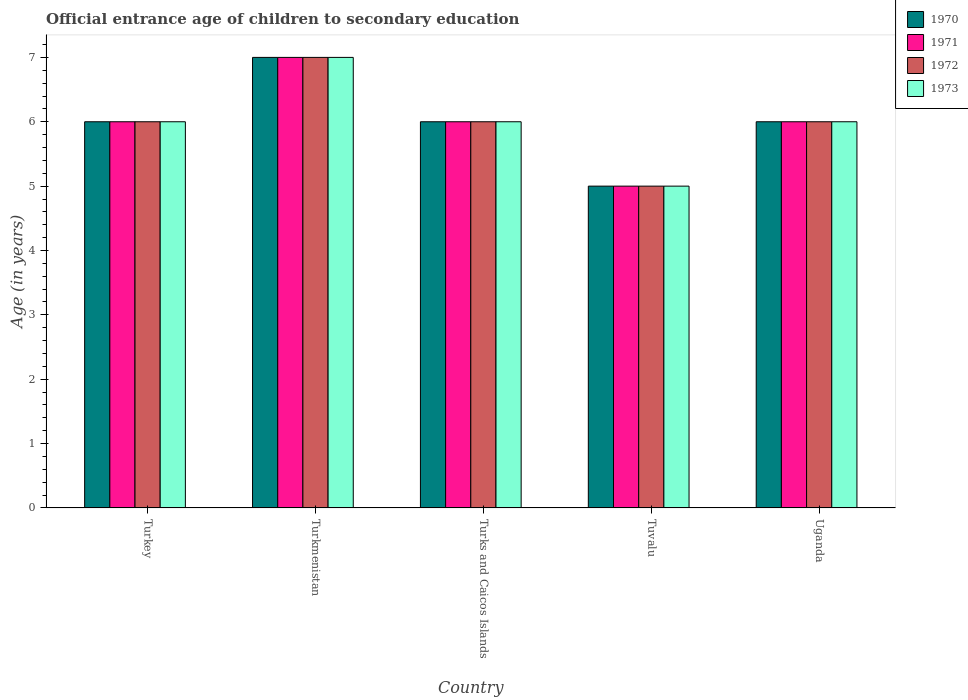How many different coloured bars are there?
Give a very brief answer. 4. Are the number of bars per tick equal to the number of legend labels?
Ensure brevity in your answer.  Yes. How many bars are there on the 3rd tick from the right?
Your response must be concise. 4. What is the label of the 2nd group of bars from the left?
Provide a short and direct response. Turkmenistan. What is the secondary school starting age of children in 1970 in Turkmenistan?
Ensure brevity in your answer.  7. Across all countries, what is the maximum secondary school starting age of children in 1970?
Provide a succinct answer. 7. In which country was the secondary school starting age of children in 1971 maximum?
Give a very brief answer. Turkmenistan. In which country was the secondary school starting age of children in 1972 minimum?
Provide a succinct answer. Tuvalu. What is the difference between the secondary school starting age of children in 1972 in Turks and Caicos Islands and that in Uganda?
Your answer should be compact. 0. What is the average secondary school starting age of children in 1971 per country?
Ensure brevity in your answer.  6. What is the ratio of the secondary school starting age of children in 1973 in Turkey to that in Turks and Caicos Islands?
Offer a very short reply. 1. Is the difference between the secondary school starting age of children in 1973 in Turks and Caicos Islands and Uganda greater than the difference between the secondary school starting age of children in 1970 in Turks and Caicos Islands and Uganda?
Your answer should be very brief. No. What is the difference between the highest and the second highest secondary school starting age of children in 1972?
Make the answer very short. -1. Is the sum of the secondary school starting age of children in 1971 in Turkey and Tuvalu greater than the maximum secondary school starting age of children in 1972 across all countries?
Provide a succinct answer. Yes. Is it the case that in every country, the sum of the secondary school starting age of children in 1970 and secondary school starting age of children in 1973 is greater than the sum of secondary school starting age of children in 1971 and secondary school starting age of children in 1972?
Your answer should be compact. No. What does the 3rd bar from the left in Turkmenistan represents?
Keep it short and to the point. 1972. What does the 2nd bar from the right in Turks and Caicos Islands represents?
Your response must be concise. 1972. Are all the bars in the graph horizontal?
Give a very brief answer. No. How many countries are there in the graph?
Ensure brevity in your answer.  5. Does the graph contain any zero values?
Your answer should be compact. No. Where does the legend appear in the graph?
Your answer should be compact. Top right. What is the title of the graph?
Make the answer very short. Official entrance age of children to secondary education. Does "2002" appear as one of the legend labels in the graph?
Your answer should be very brief. No. What is the label or title of the X-axis?
Ensure brevity in your answer.  Country. What is the label or title of the Y-axis?
Offer a terse response. Age (in years). What is the Age (in years) of 1972 in Turkey?
Offer a very short reply. 6. What is the Age (in years) in 1970 in Turks and Caicos Islands?
Your response must be concise. 6. What is the Age (in years) of 1971 in Turks and Caicos Islands?
Offer a very short reply. 6. What is the Age (in years) of 1972 in Turks and Caicos Islands?
Ensure brevity in your answer.  6. What is the Age (in years) in 1973 in Turks and Caicos Islands?
Provide a short and direct response. 6. What is the Age (in years) in 1970 in Tuvalu?
Make the answer very short. 5. What is the Age (in years) in 1970 in Uganda?
Give a very brief answer. 6. What is the Age (in years) of 1971 in Uganda?
Your answer should be very brief. 6. Across all countries, what is the maximum Age (in years) in 1972?
Your response must be concise. 7. Across all countries, what is the maximum Age (in years) of 1973?
Offer a very short reply. 7. Across all countries, what is the minimum Age (in years) in 1971?
Offer a terse response. 5. Across all countries, what is the minimum Age (in years) of 1973?
Offer a very short reply. 5. What is the total Age (in years) of 1970 in the graph?
Your response must be concise. 30. What is the total Age (in years) of 1972 in the graph?
Provide a short and direct response. 30. What is the total Age (in years) in 1973 in the graph?
Keep it short and to the point. 30. What is the difference between the Age (in years) in 1970 in Turkey and that in Turkmenistan?
Keep it short and to the point. -1. What is the difference between the Age (in years) in 1971 in Turkey and that in Turkmenistan?
Your response must be concise. -1. What is the difference between the Age (in years) of 1970 in Turkey and that in Turks and Caicos Islands?
Provide a succinct answer. 0. What is the difference between the Age (in years) of 1972 in Turkey and that in Turks and Caicos Islands?
Offer a terse response. 0. What is the difference between the Age (in years) in 1972 in Turkey and that in Tuvalu?
Provide a short and direct response. 1. What is the difference between the Age (in years) in 1973 in Turkmenistan and that in Turks and Caicos Islands?
Your response must be concise. 1. What is the difference between the Age (in years) of 1970 in Turkmenistan and that in Tuvalu?
Your answer should be very brief. 2. What is the difference between the Age (in years) of 1973 in Turkmenistan and that in Tuvalu?
Your response must be concise. 2. What is the difference between the Age (in years) in 1971 in Turkmenistan and that in Uganda?
Your response must be concise. 1. What is the difference between the Age (in years) in 1972 in Turkmenistan and that in Uganda?
Make the answer very short. 1. What is the difference between the Age (in years) in 1971 in Turks and Caicos Islands and that in Tuvalu?
Your answer should be very brief. 1. What is the difference between the Age (in years) in 1972 in Turks and Caicos Islands and that in Tuvalu?
Keep it short and to the point. 1. What is the difference between the Age (in years) in 1973 in Turks and Caicos Islands and that in Tuvalu?
Make the answer very short. 1. What is the difference between the Age (in years) of 1971 in Turks and Caicos Islands and that in Uganda?
Offer a very short reply. 0. What is the difference between the Age (in years) of 1970 in Tuvalu and that in Uganda?
Your answer should be very brief. -1. What is the difference between the Age (in years) of 1971 in Tuvalu and that in Uganda?
Ensure brevity in your answer.  -1. What is the difference between the Age (in years) in 1970 in Turkey and the Age (in years) in 1971 in Turkmenistan?
Your response must be concise. -1. What is the difference between the Age (in years) of 1970 in Turkey and the Age (in years) of 1972 in Turkmenistan?
Ensure brevity in your answer.  -1. What is the difference between the Age (in years) of 1970 in Turkey and the Age (in years) of 1973 in Turkmenistan?
Provide a short and direct response. -1. What is the difference between the Age (in years) in 1972 in Turkey and the Age (in years) in 1973 in Turkmenistan?
Provide a short and direct response. -1. What is the difference between the Age (in years) in 1970 in Turkey and the Age (in years) in 1971 in Turks and Caicos Islands?
Give a very brief answer. 0. What is the difference between the Age (in years) in 1970 in Turkey and the Age (in years) in 1972 in Turks and Caicos Islands?
Ensure brevity in your answer.  0. What is the difference between the Age (in years) of 1970 in Turkey and the Age (in years) of 1973 in Turks and Caicos Islands?
Make the answer very short. 0. What is the difference between the Age (in years) of 1971 in Turkey and the Age (in years) of 1973 in Turks and Caicos Islands?
Give a very brief answer. 0. What is the difference between the Age (in years) in 1972 in Turkey and the Age (in years) in 1973 in Turks and Caicos Islands?
Your answer should be compact. 0. What is the difference between the Age (in years) of 1972 in Turkey and the Age (in years) of 1973 in Tuvalu?
Your answer should be very brief. 1. What is the difference between the Age (in years) of 1970 in Turkey and the Age (in years) of 1972 in Uganda?
Ensure brevity in your answer.  0. What is the difference between the Age (in years) of 1971 in Turkey and the Age (in years) of 1972 in Uganda?
Ensure brevity in your answer.  0. What is the difference between the Age (in years) of 1972 in Turkey and the Age (in years) of 1973 in Uganda?
Your response must be concise. 0. What is the difference between the Age (in years) in 1972 in Turkmenistan and the Age (in years) in 1973 in Turks and Caicos Islands?
Keep it short and to the point. 1. What is the difference between the Age (in years) in 1970 in Turkmenistan and the Age (in years) in 1972 in Tuvalu?
Offer a very short reply. 2. What is the difference between the Age (in years) of 1970 in Turkmenistan and the Age (in years) of 1973 in Tuvalu?
Offer a very short reply. 2. What is the difference between the Age (in years) of 1972 in Turkmenistan and the Age (in years) of 1973 in Tuvalu?
Offer a very short reply. 2. What is the difference between the Age (in years) of 1971 in Turkmenistan and the Age (in years) of 1973 in Uganda?
Provide a succinct answer. 1. What is the difference between the Age (in years) in 1970 in Turks and Caicos Islands and the Age (in years) in 1971 in Tuvalu?
Your answer should be very brief. 1. What is the difference between the Age (in years) in 1971 in Turks and Caicos Islands and the Age (in years) in 1972 in Tuvalu?
Provide a succinct answer. 1. What is the difference between the Age (in years) of 1971 in Turks and Caicos Islands and the Age (in years) of 1973 in Tuvalu?
Give a very brief answer. 1. What is the difference between the Age (in years) in 1972 in Turks and Caicos Islands and the Age (in years) in 1973 in Tuvalu?
Ensure brevity in your answer.  1. What is the difference between the Age (in years) in 1970 in Turks and Caicos Islands and the Age (in years) in 1971 in Uganda?
Provide a short and direct response. 0. What is the difference between the Age (in years) of 1970 in Turks and Caicos Islands and the Age (in years) of 1973 in Uganda?
Give a very brief answer. 0. What is the difference between the Age (in years) in 1971 in Turks and Caicos Islands and the Age (in years) in 1973 in Uganda?
Offer a terse response. 0. What is the difference between the Age (in years) of 1970 in Tuvalu and the Age (in years) of 1973 in Uganda?
Ensure brevity in your answer.  -1. What is the difference between the Age (in years) in 1971 in Tuvalu and the Age (in years) in 1973 in Uganda?
Your answer should be very brief. -1. What is the difference between the Age (in years) of 1972 in Tuvalu and the Age (in years) of 1973 in Uganda?
Give a very brief answer. -1. What is the average Age (in years) in 1972 per country?
Provide a succinct answer. 6. What is the difference between the Age (in years) in 1970 and Age (in years) in 1971 in Turkey?
Keep it short and to the point. 0. What is the difference between the Age (in years) in 1970 and Age (in years) in 1973 in Turkey?
Your response must be concise. 0. What is the difference between the Age (in years) of 1971 and Age (in years) of 1973 in Turkey?
Keep it short and to the point. 0. What is the difference between the Age (in years) of 1972 and Age (in years) of 1973 in Turkey?
Your answer should be very brief. 0. What is the difference between the Age (in years) in 1971 and Age (in years) in 1972 in Turkmenistan?
Make the answer very short. 0. What is the difference between the Age (in years) in 1971 and Age (in years) in 1973 in Turkmenistan?
Provide a short and direct response. 0. What is the difference between the Age (in years) of 1970 and Age (in years) of 1971 in Turks and Caicos Islands?
Give a very brief answer. 0. What is the difference between the Age (in years) in 1970 and Age (in years) in 1972 in Turks and Caicos Islands?
Provide a succinct answer. 0. What is the difference between the Age (in years) in 1970 and Age (in years) in 1973 in Turks and Caicos Islands?
Offer a terse response. 0. What is the difference between the Age (in years) of 1971 and Age (in years) of 1972 in Turks and Caicos Islands?
Your answer should be compact. 0. What is the difference between the Age (in years) in 1970 and Age (in years) in 1971 in Tuvalu?
Provide a short and direct response. 0. What is the difference between the Age (in years) of 1971 and Age (in years) of 1973 in Tuvalu?
Offer a very short reply. 0. What is the difference between the Age (in years) of 1972 and Age (in years) of 1973 in Tuvalu?
Keep it short and to the point. 0. What is the difference between the Age (in years) in 1970 and Age (in years) in 1972 in Uganda?
Your answer should be compact. 0. What is the difference between the Age (in years) of 1970 and Age (in years) of 1973 in Uganda?
Provide a short and direct response. 0. What is the difference between the Age (in years) of 1971 and Age (in years) of 1973 in Uganda?
Your answer should be compact. 0. What is the ratio of the Age (in years) of 1970 in Turkey to that in Turkmenistan?
Make the answer very short. 0.86. What is the ratio of the Age (in years) of 1972 in Turkey to that in Turkmenistan?
Provide a succinct answer. 0.86. What is the ratio of the Age (in years) in 1973 in Turkey to that in Turkmenistan?
Your answer should be compact. 0.86. What is the ratio of the Age (in years) in 1971 in Turkey to that in Turks and Caicos Islands?
Your answer should be compact. 1. What is the ratio of the Age (in years) of 1972 in Turkey to that in Turks and Caicos Islands?
Keep it short and to the point. 1. What is the ratio of the Age (in years) of 1971 in Turkey to that in Tuvalu?
Provide a succinct answer. 1.2. What is the ratio of the Age (in years) of 1970 in Turkey to that in Uganda?
Provide a short and direct response. 1. What is the ratio of the Age (in years) of 1971 in Turkey to that in Uganda?
Your response must be concise. 1. What is the ratio of the Age (in years) in 1972 in Turkey to that in Uganda?
Keep it short and to the point. 1. What is the ratio of the Age (in years) of 1970 in Turkmenistan to that in Turks and Caicos Islands?
Your answer should be very brief. 1.17. What is the ratio of the Age (in years) of 1972 in Turkmenistan to that in Turks and Caicos Islands?
Make the answer very short. 1.17. What is the ratio of the Age (in years) in 1970 in Turkmenistan to that in Tuvalu?
Ensure brevity in your answer.  1.4. What is the ratio of the Age (in years) in 1973 in Turkmenistan to that in Tuvalu?
Offer a terse response. 1.4. What is the ratio of the Age (in years) of 1970 in Turkmenistan to that in Uganda?
Provide a short and direct response. 1.17. What is the ratio of the Age (in years) in 1971 in Turkmenistan to that in Uganda?
Your response must be concise. 1.17. What is the ratio of the Age (in years) in 1970 in Turks and Caicos Islands to that in Tuvalu?
Offer a terse response. 1.2. What is the ratio of the Age (in years) in 1972 in Turks and Caicos Islands to that in Tuvalu?
Offer a very short reply. 1.2. What is the ratio of the Age (in years) in 1970 in Turks and Caicos Islands to that in Uganda?
Keep it short and to the point. 1. What is the ratio of the Age (in years) in 1973 in Turks and Caicos Islands to that in Uganda?
Your response must be concise. 1. What is the ratio of the Age (in years) of 1971 in Tuvalu to that in Uganda?
Keep it short and to the point. 0.83. What is the ratio of the Age (in years) in 1973 in Tuvalu to that in Uganda?
Ensure brevity in your answer.  0.83. What is the difference between the highest and the second highest Age (in years) in 1972?
Your answer should be compact. 1. What is the difference between the highest and the second highest Age (in years) of 1973?
Keep it short and to the point. 1. What is the difference between the highest and the lowest Age (in years) of 1971?
Your answer should be very brief. 2. What is the difference between the highest and the lowest Age (in years) in 1972?
Offer a terse response. 2. 